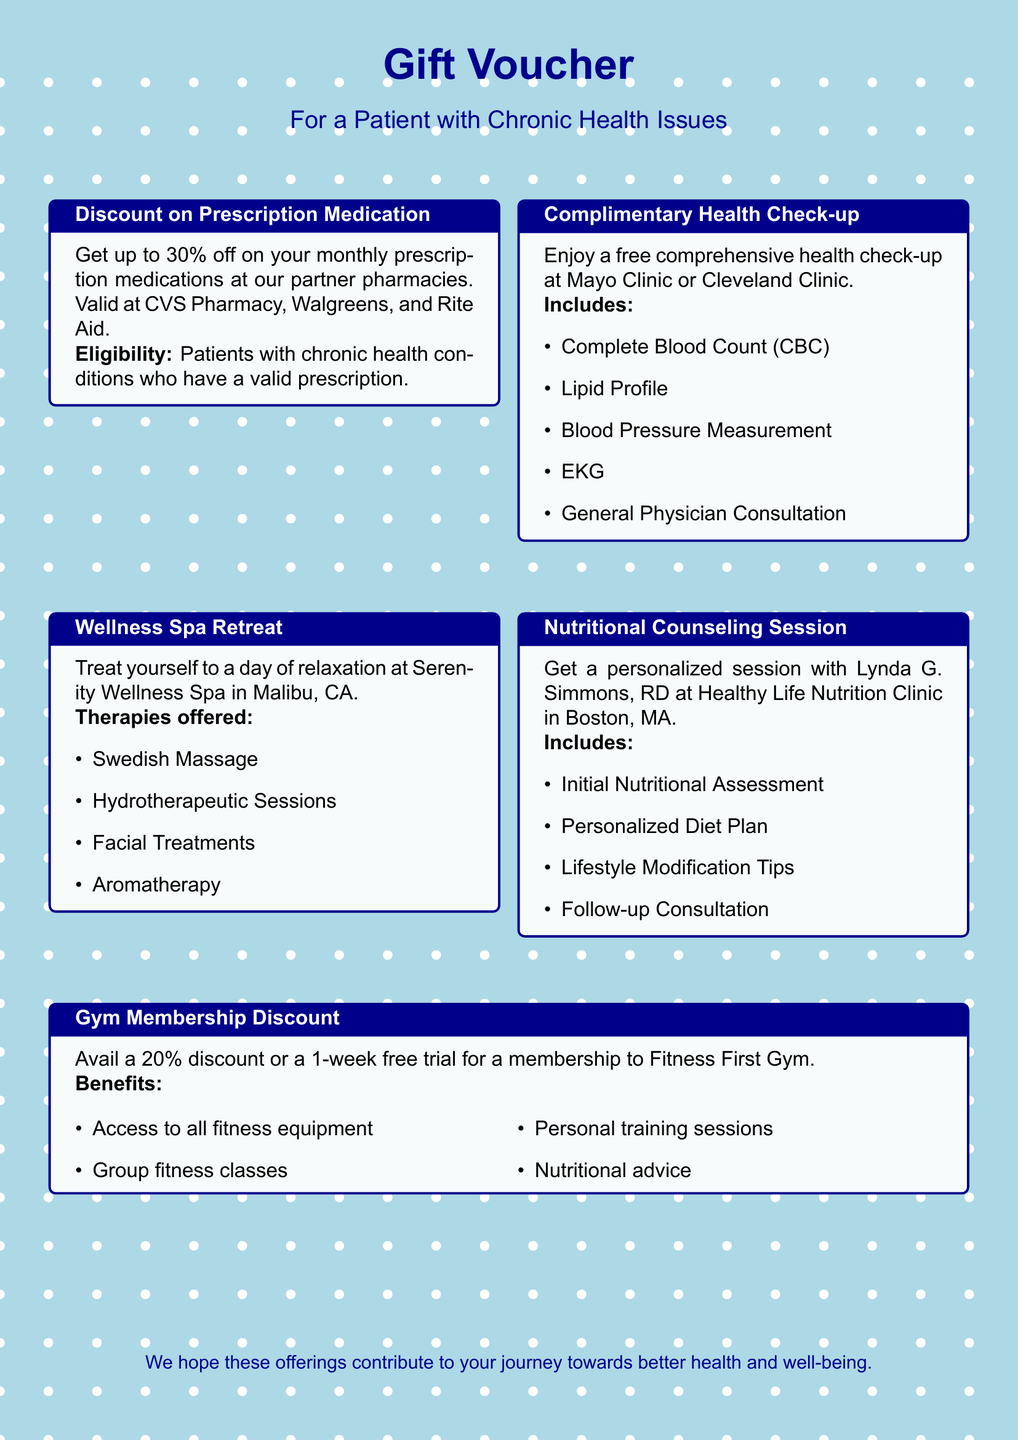What is the percentage discount on prescription medication? The document states that you can get up to 30% off on your monthly prescription medications.
Answer: 30% Which pharmacies are participating in the prescription discount? The participating pharmacies listed are CVS Pharmacy, Walgreens, and Rite Aid.
Answer: CVS Pharmacy, Walgreens, and Rite Aid What is included in the complimentary health check-up? The document lists tests like Complete Blood Count (CBC), Lipid Profile, Blood Pressure Measurement, EKG, and General Physician Consultation as included.
Answer: CBC, Lipid Profile, Blood Pressure Measurement, EKG, General Physician Consultation Where is the wellness spa located? The document specifies that the Serenity Wellness Spa is located in Malibu, CA.
Answer: Malibu, CA What is the benefit of the gym membership discount? The document mentions the benefits such as access to fitness equipment, group classes, personal training, and nutritional advice.
Answer: Access to all fitness equipment, group fitness classes, personal training sessions, nutritional advice Who provides the nutritional counseling session? The document states that the session is with Lynda G. Simmons, RD at Healthy Life Nutrition Clinic.
Answer: Lynda G. Simmons, RD How long is the gym membership trial? The document specifies that the offer includes a 1-week free trial for the membership.
Answer: 1-week What type of therapies are available at the wellness spa? The document lists therapies offered such as Swedish Massage, Hydrotherapeutic Sessions, Facial Treatments, and Aromatherapy.
Answer: Swedish Massage, Hydrotherapeutic Sessions, Facial Treatments, Aromatherapy What color palette is used in the document? The document utilizes calming colors like light blue and dark blue throughout.
Answer: Light blue and dark blue 